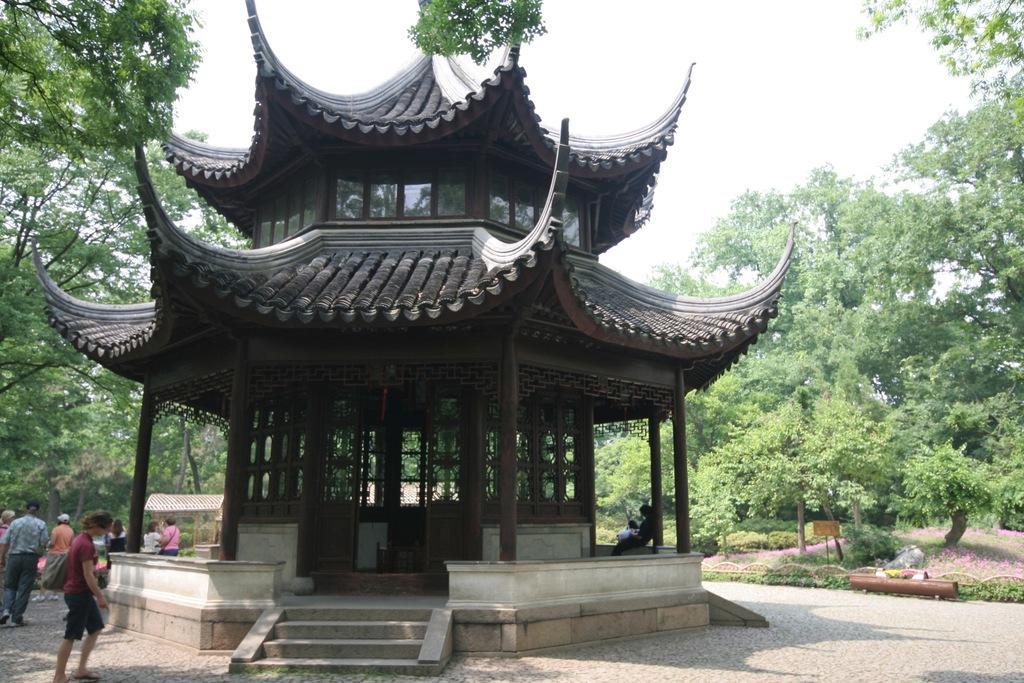How would you summarize this image in a sentence or two? This picture might be taken from outside of the city and it is sunny. In this image, on the left side, we can see a group of people, trees. In the middle of the image, we can see a building, in the building, we can see a person sitting, pillars. On the right side, we can see some trees. At the top, we can see a sky, at the bottom, we can see a grass and a land. 